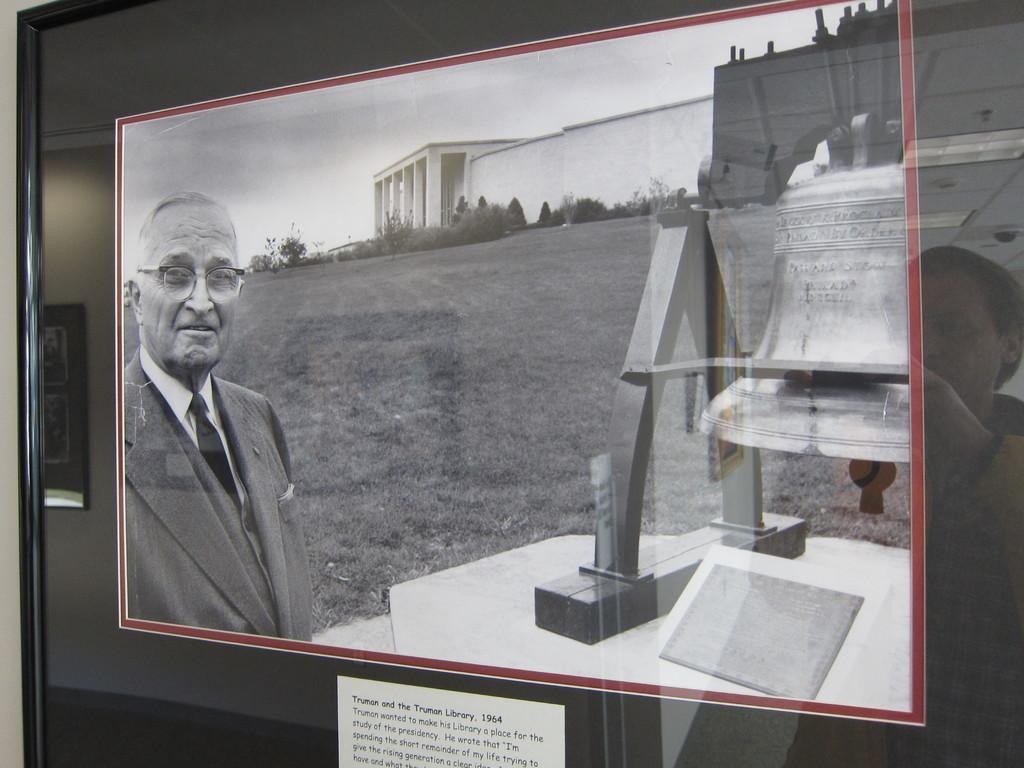What is on the glass in the image? There are posts on the glass in the image. Can you describe the person visible behind the glass? Unfortunately, the provided facts do not give any information about the person's appearance or actions. What might be the purpose of the posts on the glass? The purpose of the posts on the glass is not specified in the provided facts. What type of lettuce is being requested by the person behind the glass? There is no lettuce or request present in the image. What organization does the person behind the glass represent? There is no information about the person's affiliation or the organization they might represent. 